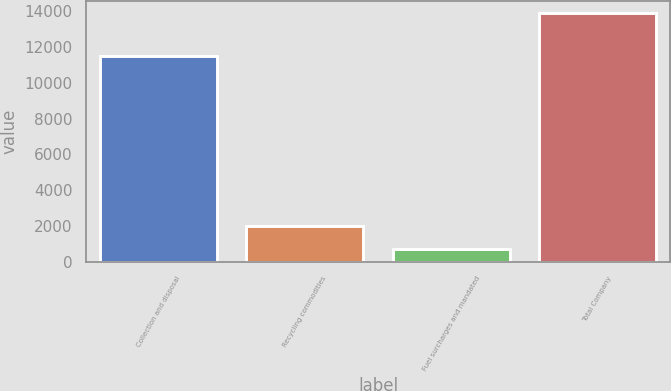Convert chart to OTSL. <chart><loc_0><loc_0><loc_500><loc_500><bar_chart><fcel>Collection and disposal<fcel>Recycling commodities<fcel>Fuel surcharges and mandated<fcel>Total Company<nl><fcel>11512<fcel>2004.9<fcel>684<fcel>13893<nl></chart> 